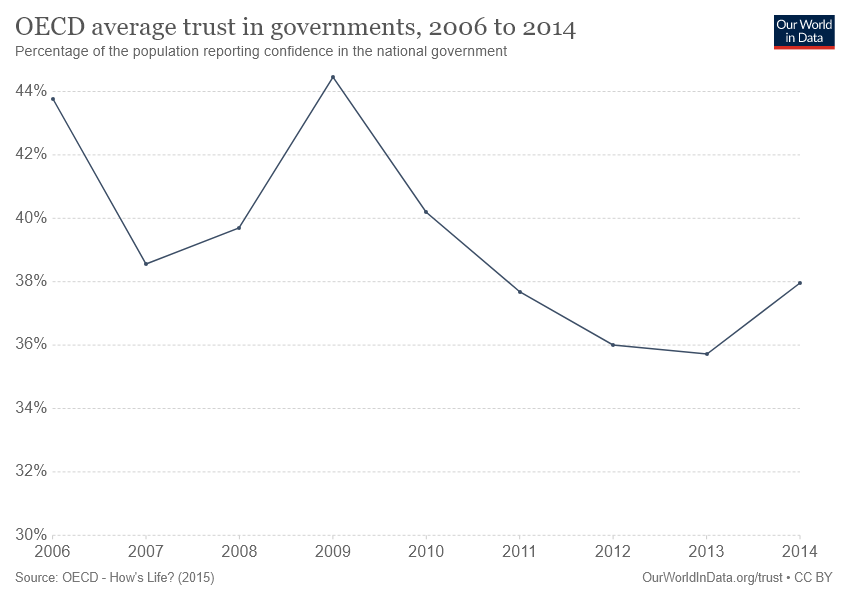Draw attention to some important aspects in this diagram. To find the average of the largest value in the chart with the last data point, which is 44.5, we can use 41.25 as the lowest value. Between 2006 and 2014, the chart shows the number of people who have died from the use of tobacco. 